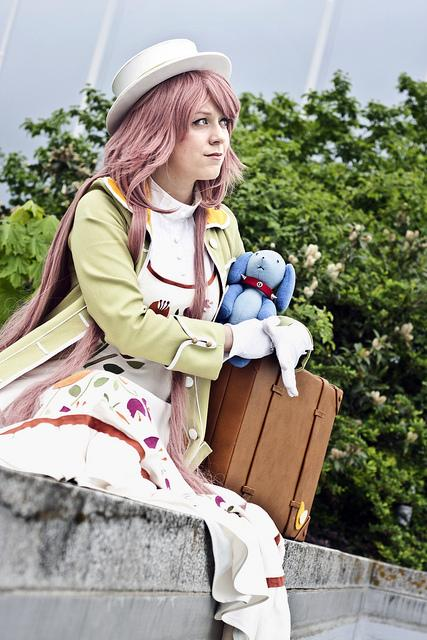What is next to the girl?

Choices:
A) pumpkin
B) luggage
C) apple
D) cow luggage 